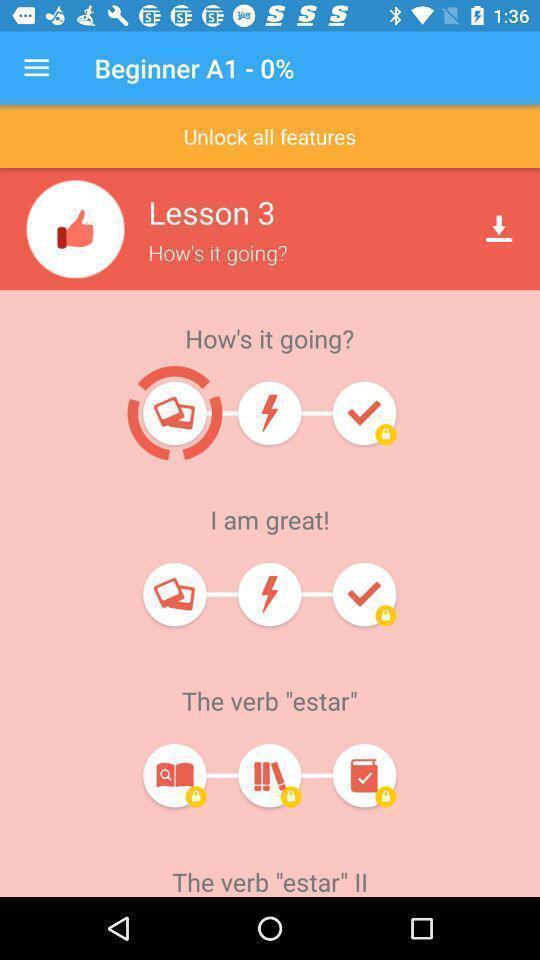Summarize the main components in this picture. Screen displaying multiple feedback options. 